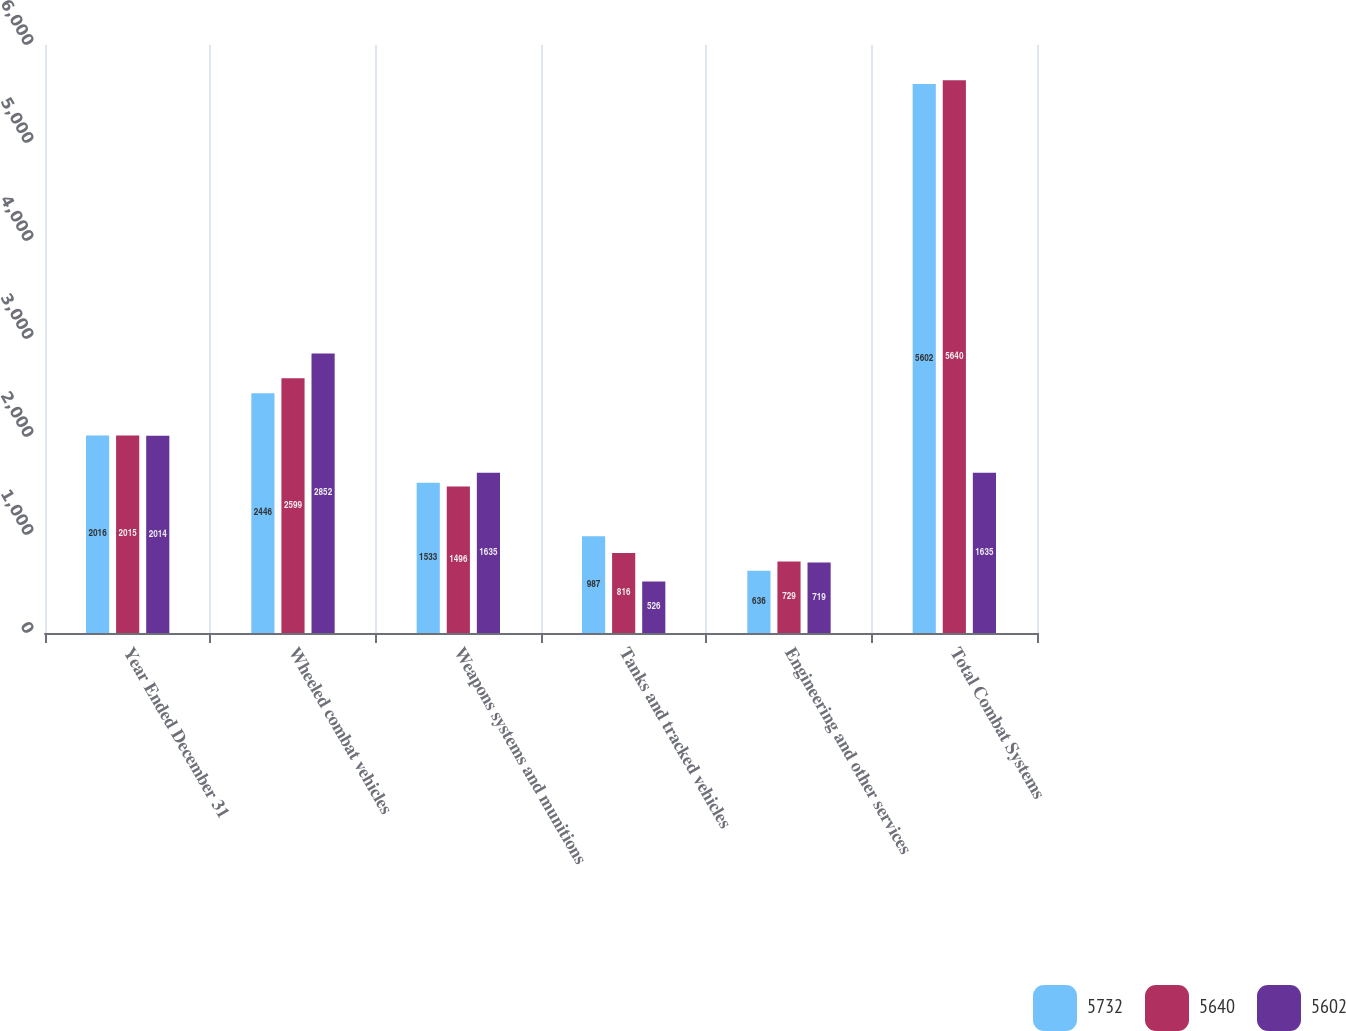Convert chart. <chart><loc_0><loc_0><loc_500><loc_500><stacked_bar_chart><ecel><fcel>Year Ended December 31<fcel>Wheeled combat vehicles<fcel>Weapons systems and munitions<fcel>Tanks and tracked vehicles<fcel>Engineering and other services<fcel>Total Combat Systems<nl><fcel>5732<fcel>2016<fcel>2446<fcel>1533<fcel>987<fcel>636<fcel>5602<nl><fcel>5640<fcel>2015<fcel>2599<fcel>1496<fcel>816<fcel>729<fcel>5640<nl><fcel>5602<fcel>2014<fcel>2852<fcel>1635<fcel>526<fcel>719<fcel>1635<nl></chart> 